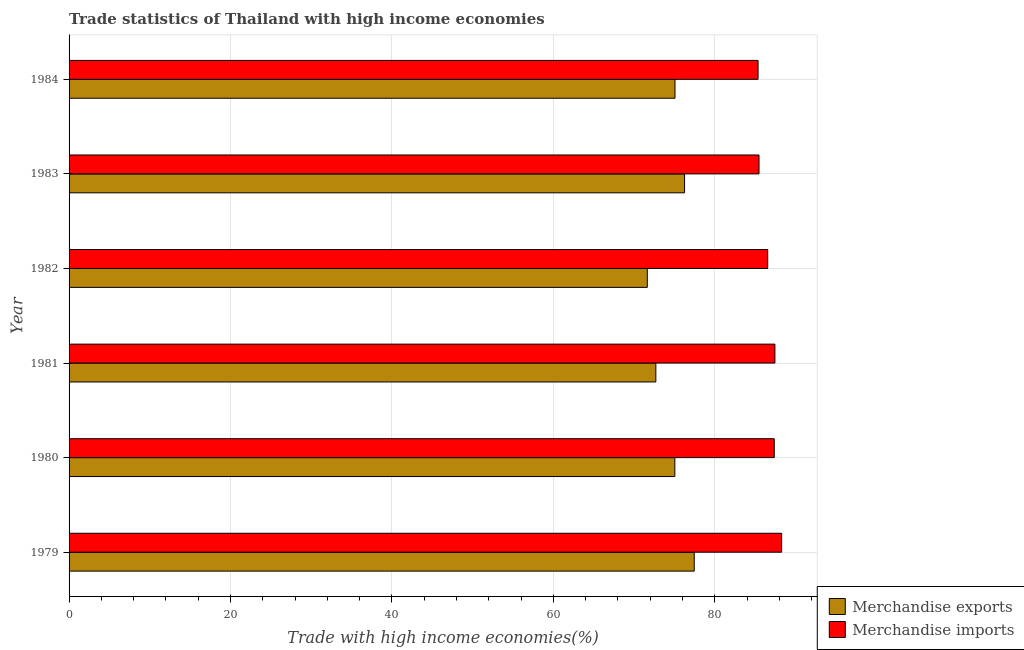How many different coloured bars are there?
Your answer should be very brief. 2. How many groups of bars are there?
Offer a terse response. 6. Are the number of bars per tick equal to the number of legend labels?
Keep it short and to the point. Yes. How many bars are there on the 1st tick from the top?
Your answer should be very brief. 2. What is the label of the 4th group of bars from the top?
Provide a succinct answer. 1981. What is the merchandise exports in 1983?
Offer a very short reply. 76.26. Across all years, what is the maximum merchandise imports?
Your answer should be compact. 88.29. Across all years, what is the minimum merchandise exports?
Provide a short and direct response. 71.64. In which year was the merchandise exports maximum?
Make the answer very short. 1979. In which year was the merchandise imports minimum?
Provide a short and direct response. 1984. What is the total merchandise imports in the graph?
Provide a succinct answer. 520.52. What is the difference between the merchandise imports in 1983 and that in 1984?
Provide a succinct answer. 0.12. What is the difference between the merchandise imports in 1981 and the merchandise exports in 1980?
Provide a short and direct response. 12.4. What is the average merchandise exports per year?
Offer a very short reply. 74.7. In the year 1984, what is the difference between the merchandise imports and merchandise exports?
Provide a short and direct response. 10.29. What is the ratio of the merchandise exports in 1980 to that in 1982?
Provide a short and direct response. 1.05. Is the merchandise exports in 1979 less than that in 1984?
Offer a terse response. No. What is the difference between the highest and the second highest merchandise exports?
Ensure brevity in your answer.  1.2. What is the difference between the highest and the lowest merchandise imports?
Keep it short and to the point. 2.92. Is the sum of the merchandise imports in 1979 and 1982 greater than the maximum merchandise exports across all years?
Provide a short and direct response. Yes. What does the 1st bar from the top in 1980 represents?
Provide a short and direct response. Merchandise imports. What does the 1st bar from the bottom in 1981 represents?
Ensure brevity in your answer.  Merchandise exports. Are all the bars in the graph horizontal?
Your answer should be very brief. Yes. What is the difference between two consecutive major ticks on the X-axis?
Make the answer very short. 20. Are the values on the major ticks of X-axis written in scientific E-notation?
Keep it short and to the point. No. Where does the legend appear in the graph?
Offer a very short reply. Bottom right. How many legend labels are there?
Ensure brevity in your answer.  2. How are the legend labels stacked?
Provide a short and direct response. Vertical. What is the title of the graph?
Provide a short and direct response. Trade statistics of Thailand with high income economies. Does "Age 65(male)" appear as one of the legend labels in the graph?
Give a very brief answer. No. What is the label or title of the X-axis?
Keep it short and to the point. Trade with high income economies(%). What is the label or title of the Y-axis?
Your answer should be compact. Year. What is the Trade with high income economies(%) in Merchandise exports in 1979?
Your answer should be very brief. 77.46. What is the Trade with high income economies(%) in Merchandise imports in 1979?
Your answer should be very brief. 88.29. What is the Trade with high income economies(%) of Merchandise exports in 1980?
Your answer should be compact. 75.06. What is the Trade with high income economies(%) of Merchandise imports in 1980?
Provide a succinct answer. 87.37. What is the Trade with high income economies(%) of Merchandise exports in 1981?
Make the answer very short. 72.7. What is the Trade with high income economies(%) of Merchandise imports in 1981?
Make the answer very short. 87.45. What is the Trade with high income economies(%) of Merchandise exports in 1982?
Offer a terse response. 71.64. What is the Trade with high income economies(%) of Merchandise imports in 1982?
Provide a short and direct response. 86.56. What is the Trade with high income economies(%) in Merchandise exports in 1983?
Give a very brief answer. 76.26. What is the Trade with high income economies(%) of Merchandise imports in 1983?
Your response must be concise. 85.48. What is the Trade with high income economies(%) of Merchandise exports in 1984?
Offer a terse response. 75.07. What is the Trade with high income economies(%) of Merchandise imports in 1984?
Your response must be concise. 85.37. Across all years, what is the maximum Trade with high income economies(%) in Merchandise exports?
Give a very brief answer. 77.46. Across all years, what is the maximum Trade with high income economies(%) of Merchandise imports?
Offer a very short reply. 88.29. Across all years, what is the minimum Trade with high income economies(%) of Merchandise exports?
Your response must be concise. 71.64. Across all years, what is the minimum Trade with high income economies(%) of Merchandise imports?
Your answer should be compact. 85.37. What is the total Trade with high income economies(%) in Merchandise exports in the graph?
Make the answer very short. 448.19. What is the total Trade with high income economies(%) in Merchandise imports in the graph?
Provide a succinct answer. 520.52. What is the difference between the Trade with high income economies(%) of Merchandise exports in 1979 and that in 1980?
Give a very brief answer. 2.4. What is the difference between the Trade with high income economies(%) of Merchandise imports in 1979 and that in 1980?
Offer a very short reply. 0.92. What is the difference between the Trade with high income economies(%) in Merchandise exports in 1979 and that in 1981?
Keep it short and to the point. 4.76. What is the difference between the Trade with high income economies(%) of Merchandise imports in 1979 and that in 1981?
Provide a succinct answer. 0.84. What is the difference between the Trade with high income economies(%) of Merchandise exports in 1979 and that in 1982?
Make the answer very short. 5.81. What is the difference between the Trade with high income economies(%) in Merchandise imports in 1979 and that in 1982?
Ensure brevity in your answer.  1.73. What is the difference between the Trade with high income economies(%) of Merchandise exports in 1979 and that in 1983?
Your answer should be compact. 1.2. What is the difference between the Trade with high income economies(%) of Merchandise imports in 1979 and that in 1983?
Offer a very short reply. 2.8. What is the difference between the Trade with high income economies(%) in Merchandise exports in 1979 and that in 1984?
Your answer should be very brief. 2.38. What is the difference between the Trade with high income economies(%) in Merchandise imports in 1979 and that in 1984?
Offer a terse response. 2.92. What is the difference between the Trade with high income economies(%) of Merchandise exports in 1980 and that in 1981?
Keep it short and to the point. 2.36. What is the difference between the Trade with high income economies(%) in Merchandise imports in 1980 and that in 1981?
Give a very brief answer. -0.08. What is the difference between the Trade with high income economies(%) in Merchandise exports in 1980 and that in 1982?
Your response must be concise. 3.41. What is the difference between the Trade with high income economies(%) in Merchandise imports in 1980 and that in 1982?
Make the answer very short. 0.81. What is the difference between the Trade with high income economies(%) in Merchandise exports in 1980 and that in 1983?
Offer a very short reply. -1.2. What is the difference between the Trade with high income economies(%) of Merchandise imports in 1980 and that in 1983?
Keep it short and to the point. 1.89. What is the difference between the Trade with high income economies(%) in Merchandise exports in 1980 and that in 1984?
Provide a succinct answer. -0.02. What is the difference between the Trade with high income economies(%) in Merchandise imports in 1980 and that in 1984?
Provide a short and direct response. 2.01. What is the difference between the Trade with high income economies(%) in Merchandise exports in 1981 and that in 1982?
Offer a very short reply. 1.06. What is the difference between the Trade with high income economies(%) in Merchandise imports in 1981 and that in 1982?
Your answer should be very brief. 0.89. What is the difference between the Trade with high income economies(%) in Merchandise exports in 1981 and that in 1983?
Keep it short and to the point. -3.56. What is the difference between the Trade with high income economies(%) in Merchandise imports in 1981 and that in 1983?
Keep it short and to the point. 1.97. What is the difference between the Trade with high income economies(%) in Merchandise exports in 1981 and that in 1984?
Offer a very short reply. -2.37. What is the difference between the Trade with high income economies(%) in Merchandise imports in 1981 and that in 1984?
Provide a short and direct response. 2.09. What is the difference between the Trade with high income economies(%) of Merchandise exports in 1982 and that in 1983?
Your response must be concise. -4.61. What is the difference between the Trade with high income economies(%) of Merchandise imports in 1982 and that in 1983?
Provide a short and direct response. 1.08. What is the difference between the Trade with high income economies(%) in Merchandise exports in 1982 and that in 1984?
Your answer should be compact. -3.43. What is the difference between the Trade with high income economies(%) in Merchandise imports in 1982 and that in 1984?
Ensure brevity in your answer.  1.2. What is the difference between the Trade with high income economies(%) of Merchandise exports in 1983 and that in 1984?
Offer a very short reply. 1.19. What is the difference between the Trade with high income economies(%) in Merchandise imports in 1983 and that in 1984?
Your answer should be very brief. 0.12. What is the difference between the Trade with high income economies(%) in Merchandise exports in 1979 and the Trade with high income economies(%) in Merchandise imports in 1980?
Your answer should be compact. -9.91. What is the difference between the Trade with high income economies(%) of Merchandise exports in 1979 and the Trade with high income economies(%) of Merchandise imports in 1981?
Offer a very short reply. -9.99. What is the difference between the Trade with high income economies(%) in Merchandise exports in 1979 and the Trade with high income economies(%) in Merchandise imports in 1982?
Provide a succinct answer. -9.11. What is the difference between the Trade with high income economies(%) of Merchandise exports in 1979 and the Trade with high income economies(%) of Merchandise imports in 1983?
Provide a short and direct response. -8.03. What is the difference between the Trade with high income economies(%) in Merchandise exports in 1979 and the Trade with high income economies(%) in Merchandise imports in 1984?
Your answer should be very brief. -7.91. What is the difference between the Trade with high income economies(%) in Merchandise exports in 1980 and the Trade with high income economies(%) in Merchandise imports in 1981?
Provide a succinct answer. -12.4. What is the difference between the Trade with high income economies(%) in Merchandise exports in 1980 and the Trade with high income economies(%) in Merchandise imports in 1982?
Offer a terse response. -11.51. What is the difference between the Trade with high income economies(%) of Merchandise exports in 1980 and the Trade with high income economies(%) of Merchandise imports in 1983?
Provide a short and direct response. -10.43. What is the difference between the Trade with high income economies(%) in Merchandise exports in 1980 and the Trade with high income economies(%) in Merchandise imports in 1984?
Offer a terse response. -10.31. What is the difference between the Trade with high income economies(%) of Merchandise exports in 1981 and the Trade with high income economies(%) of Merchandise imports in 1982?
Give a very brief answer. -13.86. What is the difference between the Trade with high income economies(%) in Merchandise exports in 1981 and the Trade with high income economies(%) in Merchandise imports in 1983?
Provide a succinct answer. -12.78. What is the difference between the Trade with high income economies(%) in Merchandise exports in 1981 and the Trade with high income economies(%) in Merchandise imports in 1984?
Your answer should be compact. -12.67. What is the difference between the Trade with high income economies(%) of Merchandise exports in 1982 and the Trade with high income economies(%) of Merchandise imports in 1983?
Your answer should be compact. -13.84. What is the difference between the Trade with high income economies(%) in Merchandise exports in 1982 and the Trade with high income economies(%) in Merchandise imports in 1984?
Your answer should be very brief. -13.72. What is the difference between the Trade with high income economies(%) of Merchandise exports in 1983 and the Trade with high income economies(%) of Merchandise imports in 1984?
Your answer should be compact. -9.11. What is the average Trade with high income economies(%) in Merchandise exports per year?
Ensure brevity in your answer.  74.7. What is the average Trade with high income economies(%) of Merchandise imports per year?
Your answer should be compact. 86.75. In the year 1979, what is the difference between the Trade with high income economies(%) of Merchandise exports and Trade with high income economies(%) of Merchandise imports?
Your response must be concise. -10.83. In the year 1980, what is the difference between the Trade with high income economies(%) of Merchandise exports and Trade with high income economies(%) of Merchandise imports?
Keep it short and to the point. -12.32. In the year 1981, what is the difference between the Trade with high income economies(%) in Merchandise exports and Trade with high income economies(%) in Merchandise imports?
Make the answer very short. -14.75. In the year 1982, what is the difference between the Trade with high income economies(%) of Merchandise exports and Trade with high income economies(%) of Merchandise imports?
Give a very brief answer. -14.92. In the year 1983, what is the difference between the Trade with high income economies(%) of Merchandise exports and Trade with high income economies(%) of Merchandise imports?
Offer a terse response. -9.22. In the year 1984, what is the difference between the Trade with high income economies(%) of Merchandise exports and Trade with high income economies(%) of Merchandise imports?
Offer a terse response. -10.29. What is the ratio of the Trade with high income economies(%) of Merchandise exports in 1979 to that in 1980?
Give a very brief answer. 1.03. What is the ratio of the Trade with high income economies(%) in Merchandise imports in 1979 to that in 1980?
Your response must be concise. 1.01. What is the ratio of the Trade with high income economies(%) in Merchandise exports in 1979 to that in 1981?
Make the answer very short. 1.07. What is the ratio of the Trade with high income economies(%) of Merchandise imports in 1979 to that in 1981?
Give a very brief answer. 1.01. What is the ratio of the Trade with high income economies(%) in Merchandise exports in 1979 to that in 1982?
Provide a succinct answer. 1.08. What is the ratio of the Trade with high income economies(%) in Merchandise imports in 1979 to that in 1982?
Ensure brevity in your answer.  1.02. What is the ratio of the Trade with high income economies(%) in Merchandise exports in 1979 to that in 1983?
Make the answer very short. 1.02. What is the ratio of the Trade with high income economies(%) in Merchandise imports in 1979 to that in 1983?
Your answer should be compact. 1.03. What is the ratio of the Trade with high income economies(%) in Merchandise exports in 1979 to that in 1984?
Your answer should be very brief. 1.03. What is the ratio of the Trade with high income economies(%) of Merchandise imports in 1979 to that in 1984?
Make the answer very short. 1.03. What is the ratio of the Trade with high income economies(%) in Merchandise exports in 1980 to that in 1981?
Offer a terse response. 1.03. What is the ratio of the Trade with high income economies(%) of Merchandise exports in 1980 to that in 1982?
Provide a succinct answer. 1.05. What is the ratio of the Trade with high income economies(%) in Merchandise imports in 1980 to that in 1982?
Your answer should be compact. 1.01. What is the ratio of the Trade with high income economies(%) of Merchandise exports in 1980 to that in 1983?
Your answer should be compact. 0.98. What is the ratio of the Trade with high income economies(%) in Merchandise imports in 1980 to that in 1983?
Offer a very short reply. 1.02. What is the ratio of the Trade with high income economies(%) in Merchandise imports in 1980 to that in 1984?
Offer a very short reply. 1.02. What is the ratio of the Trade with high income economies(%) of Merchandise exports in 1981 to that in 1982?
Provide a succinct answer. 1.01. What is the ratio of the Trade with high income economies(%) in Merchandise imports in 1981 to that in 1982?
Your answer should be very brief. 1.01. What is the ratio of the Trade with high income economies(%) in Merchandise exports in 1981 to that in 1983?
Provide a succinct answer. 0.95. What is the ratio of the Trade with high income economies(%) of Merchandise exports in 1981 to that in 1984?
Offer a terse response. 0.97. What is the ratio of the Trade with high income economies(%) of Merchandise imports in 1981 to that in 1984?
Your answer should be very brief. 1.02. What is the ratio of the Trade with high income economies(%) of Merchandise exports in 1982 to that in 1983?
Your answer should be very brief. 0.94. What is the ratio of the Trade with high income economies(%) in Merchandise imports in 1982 to that in 1983?
Provide a succinct answer. 1.01. What is the ratio of the Trade with high income economies(%) in Merchandise exports in 1982 to that in 1984?
Ensure brevity in your answer.  0.95. What is the ratio of the Trade with high income economies(%) of Merchandise exports in 1983 to that in 1984?
Keep it short and to the point. 1.02. What is the difference between the highest and the second highest Trade with high income economies(%) of Merchandise exports?
Make the answer very short. 1.2. What is the difference between the highest and the second highest Trade with high income economies(%) in Merchandise imports?
Ensure brevity in your answer.  0.84. What is the difference between the highest and the lowest Trade with high income economies(%) of Merchandise exports?
Offer a very short reply. 5.81. What is the difference between the highest and the lowest Trade with high income economies(%) in Merchandise imports?
Give a very brief answer. 2.92. 